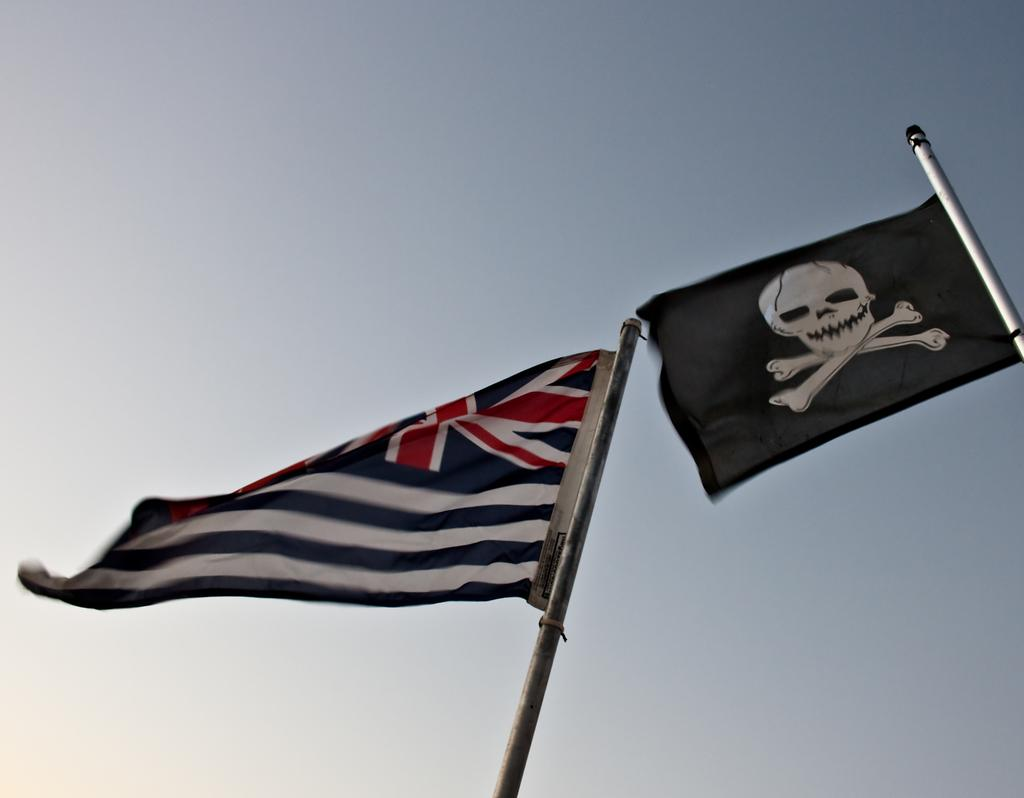What objects are present in the image that represent a country or organization? There are flags in the image. How are the flags displayed in the image? The flags are on poles. What can be seen in the background of the image? The sky is visible in the background of the image. What type of acoustics can be heard from the stage in the image? There is no stage present in the image, so it is not possible to determine the acoustics. 